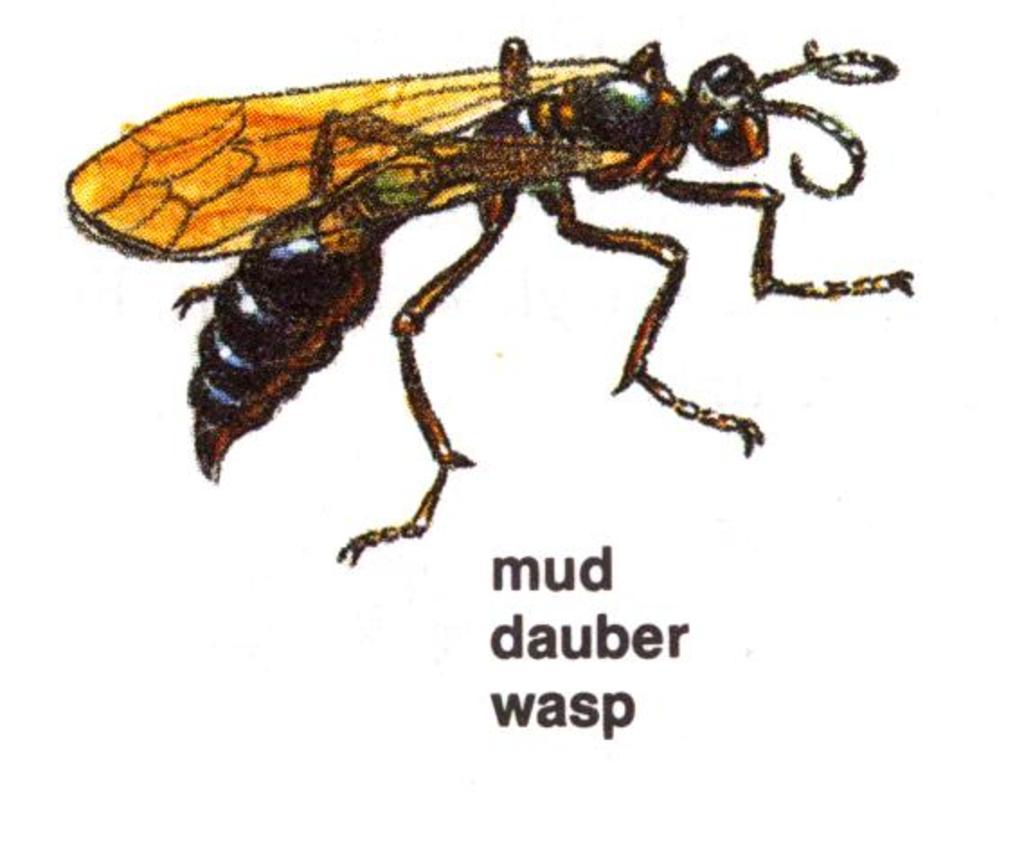Describe this image in one or two sentences. At the top of this picture there is a drawing of a fly. The background of the image is white in color. At the bottom there is a text on the image. 